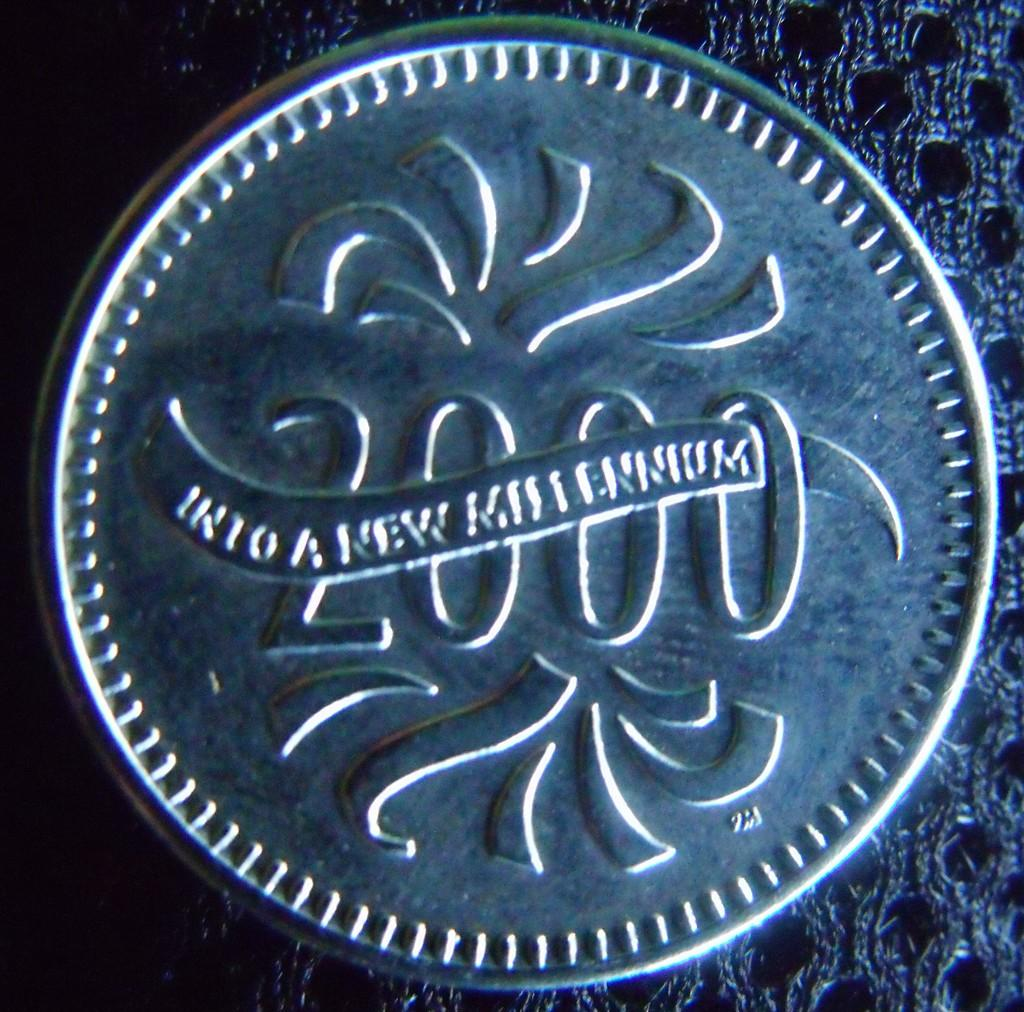What object is the main focus of the image? The main object in the image is a coin. What can be seen on the surface of the coin? The coin has a number on it, writing, and a design. What type of bead is being used by the band in the image? There is no band or bead present in the image; it only features a coin with a number, writing, and design. 